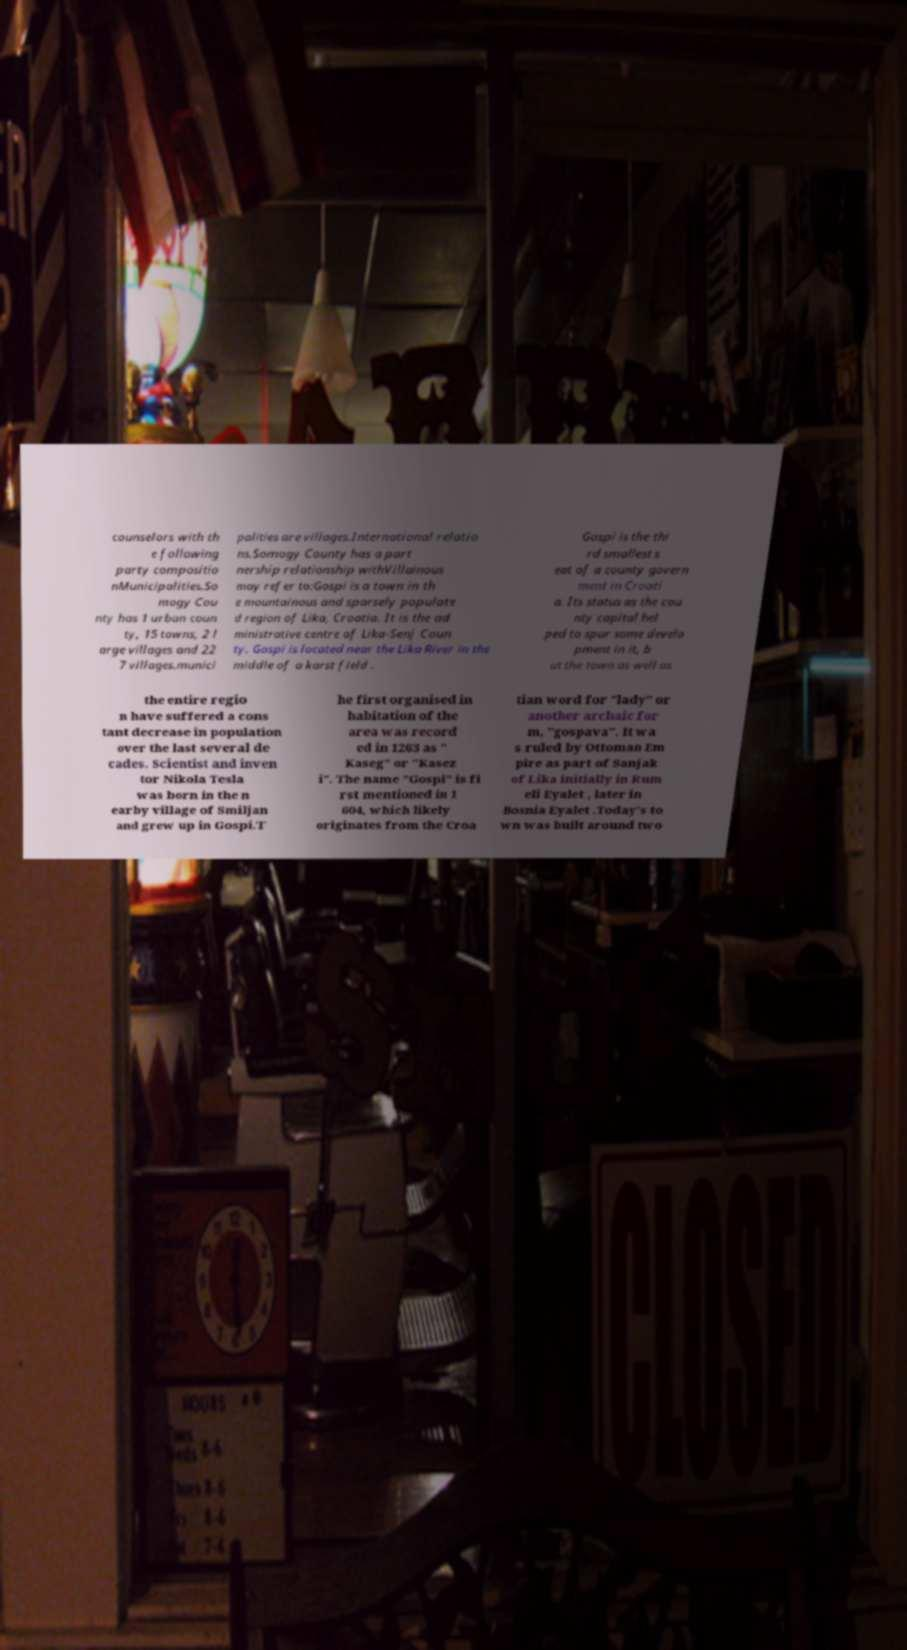Please identify and transcribe the text found in this image. counselors with th e following party compositio nMunicipalities.So mogy Cou nty has 1 urban coun ty, 15 towns, 2 l arge villages and 22 7 villages.munici palities are villages.International relatio ns.Somogy County has a part nership relationship withVillainous may refer to:Gospi is a town in th e mountainous and sparsely populate d region of Lika, Croatia. It is the ad ministrative centre of Lika-Senj Coun ty. Gospi is located near the Lika River in the middle of a karst field . Gospi is the thi rd smallest s eat of a county govern ment in Croati a. Its status as the cou nty capital hel ped to spur some develo pment in it, b ut the town as well as the entire regio n have suffered a cons tant decrease in population over the last several de cades. Scientist and inven tor Nikola Tesla was born in the n earby village of Smiljan and grew up in Gospi.T he first organised in habitation of the area was record ed in 1263 as " Kaseg" or "Kasez i". The name "Gospi" is fi rst mentioned in 1 604, which likely originates from the Croa tian word for "lady" or another archaic for m, "gospava". It wa s ruled by Ottoman Em pire as part of Sanjak of Lika initially in Rum eli Eyalet , later in Bosnia Eyalet .Today's to wn was built around two 